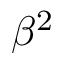<formula> <loc_0><loc_0><loc_500><loc_500>\beta ^ { 2 }</formula> 